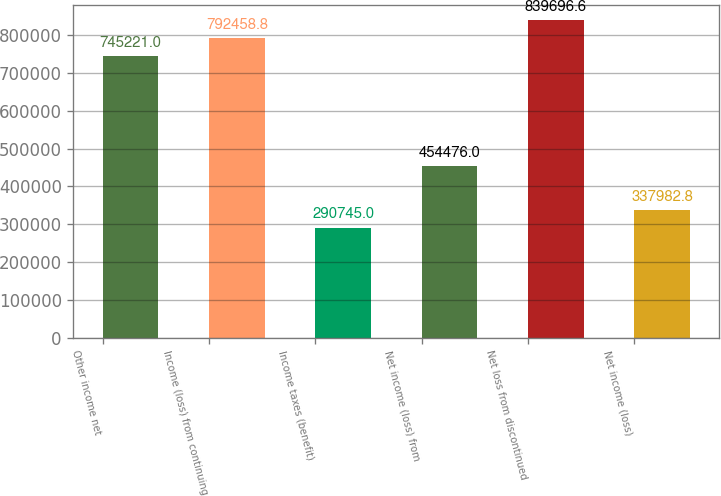Convert chart to OTSL. <chart><loc_0><loc_0><loc_500><loc_500><bar_chart><fcel>Other income net<fcel>Income (loss) from continuing<fcel>Income taxes (benefit)<fcel>Net income (loss) from<fcel>Net loss from discontinued<fcel>Net income (loss)<nl><fcel>745221<fcel>792459<fcel>290745<fcel>454476<fcel>839697<fcel>337983<nl></chart> 